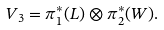<formula> <loc_0><loc_0><loc_500><loc_500>V _ { 3 } = \pi _ { 1 } ^ { * } ( L ) \otimes \pi _ { 2 } ^ { * } ( W ) .</formula> 